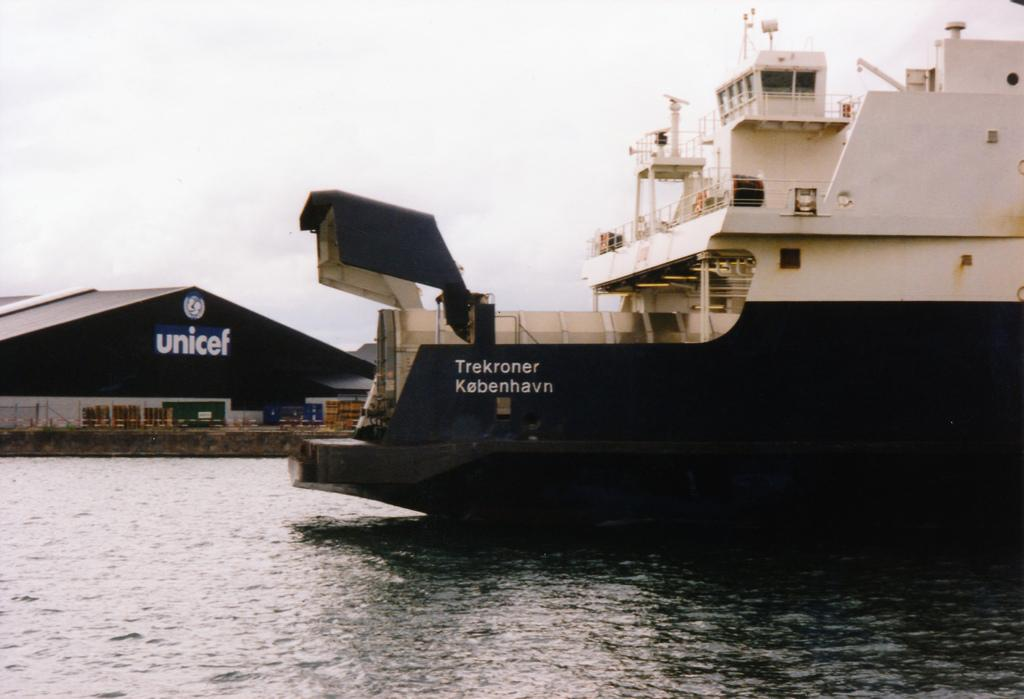<image>
Relay a brief, clear account of the picture shown. A large Ferry labelled Trekroner Kebenhavn sits in a port in front of a Unicef warehouse. 